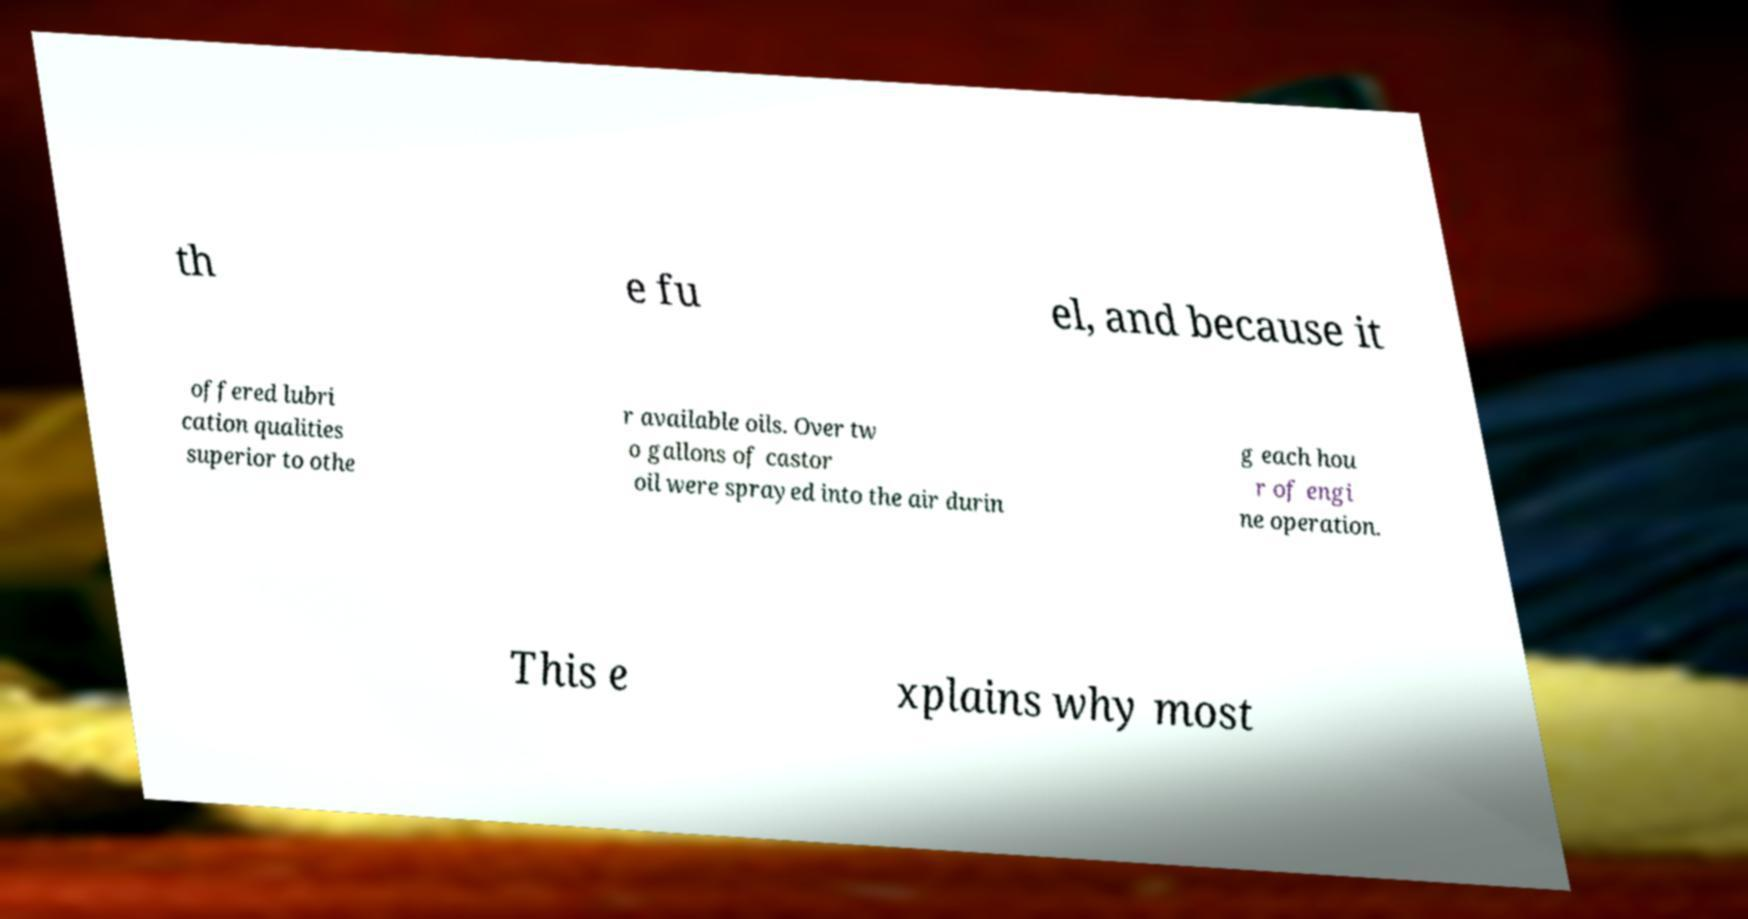Can you accurately transcribe the text from the provided image for me? th e fu el, and because it offered lubri cation qualities superior to othe r available oils. Over tw o gallons of castor oil were sprayed into the air durin g each hou r of engi ne operation. This e xplains why most 